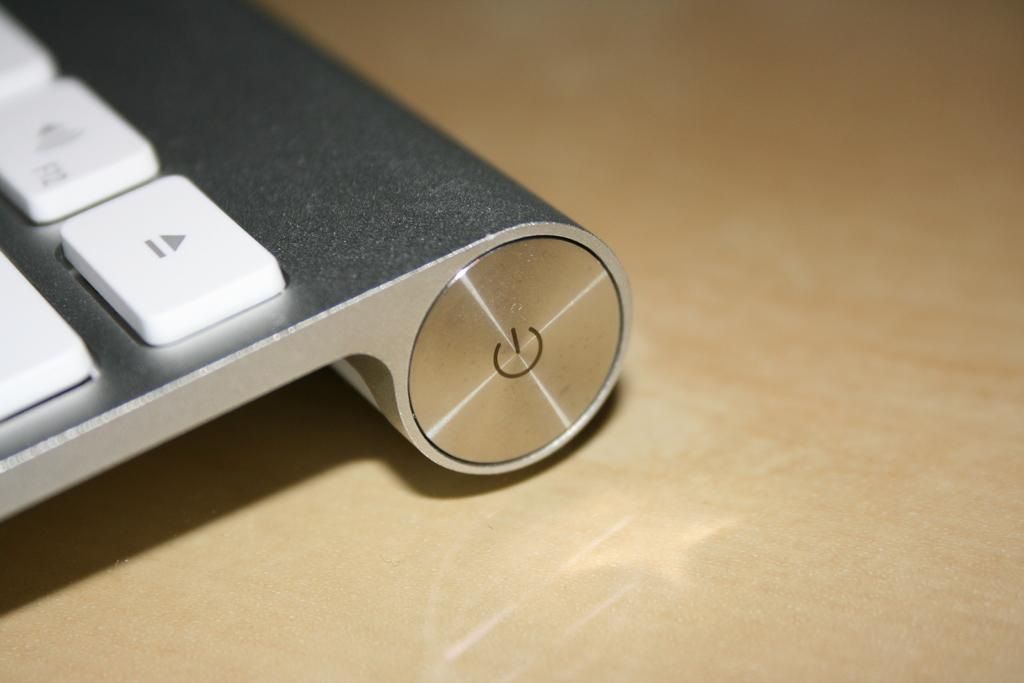What is the main object on the table in the image? There is a keyboard on the table in the image. What type of surface is the keyboard placed on? The keyboard is placed on a table in the image. What type of linen can be seen draped over the keyboard in the image? There is no linen draped over the keyboard in the image. What liquid is being used to clean the keyboard in the image? There is no liquid or cleaning activity depicted in the image; it only shows a keyboard on a table. 